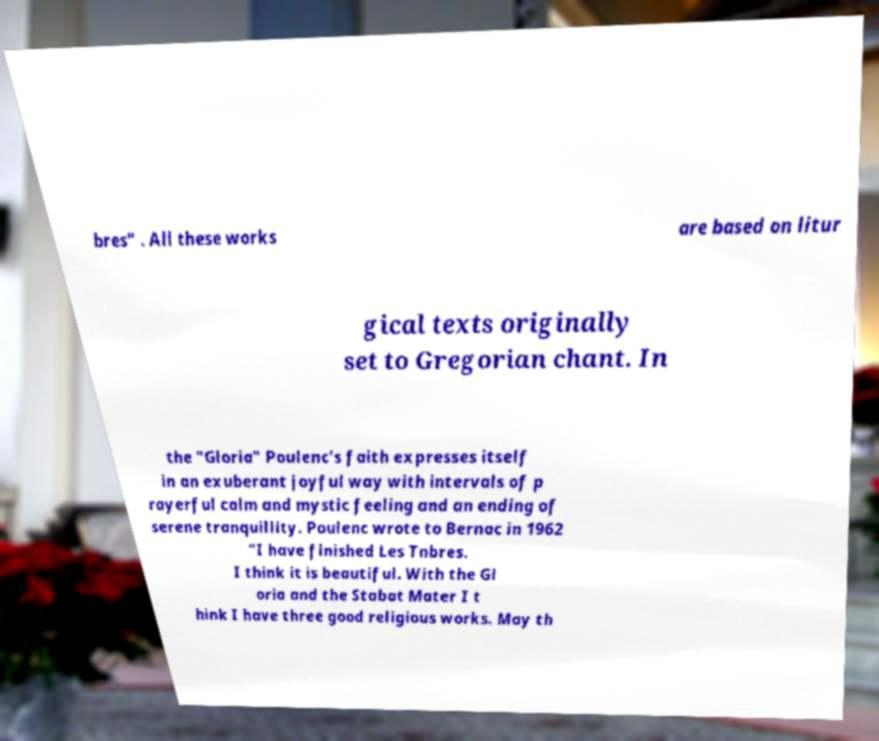For documentation purposes, I need the text within this image transcribed. Could you provide that? bres" . All these works are based on litur gical texts originally set to Gregorian chant. In the "Gloria" Poulenc's faith expresses itself in an exuberant joyful way with intervals of p rayerful calm and mystic feeling and an ending of serene tranquillity. Poulenc wrote to Bernac in 1962 "I have finished Les Tnbres. I think it is beautiful. With the Gl oria and the Stabat Mater I t hink I have three good religious works. May th 